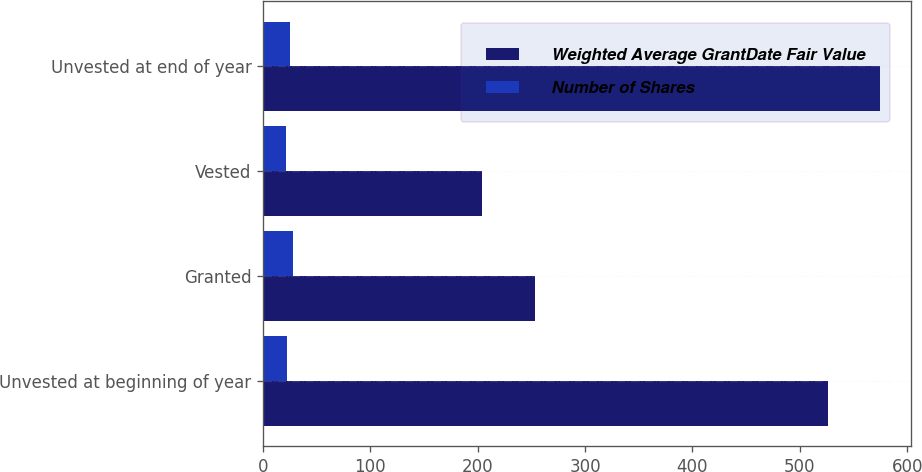Convert chart. <chart><loc_0><loc_0><loc_500><loc_500><stacked_bar_chart><ecel><fcel>Unvested at beginning of year<fcel>Granted<fcel>Vested<fcel>Unvested at end of year<nl><fcel>Weighted Average GrantDate Fair Value<fcel>526<fcel>253<fcel>204<fcel>575<nl><fcel>Number of Shares<fcel>22.69<fcel>27.86<fcel>21.81<fcel>25.28<nl></chart> 